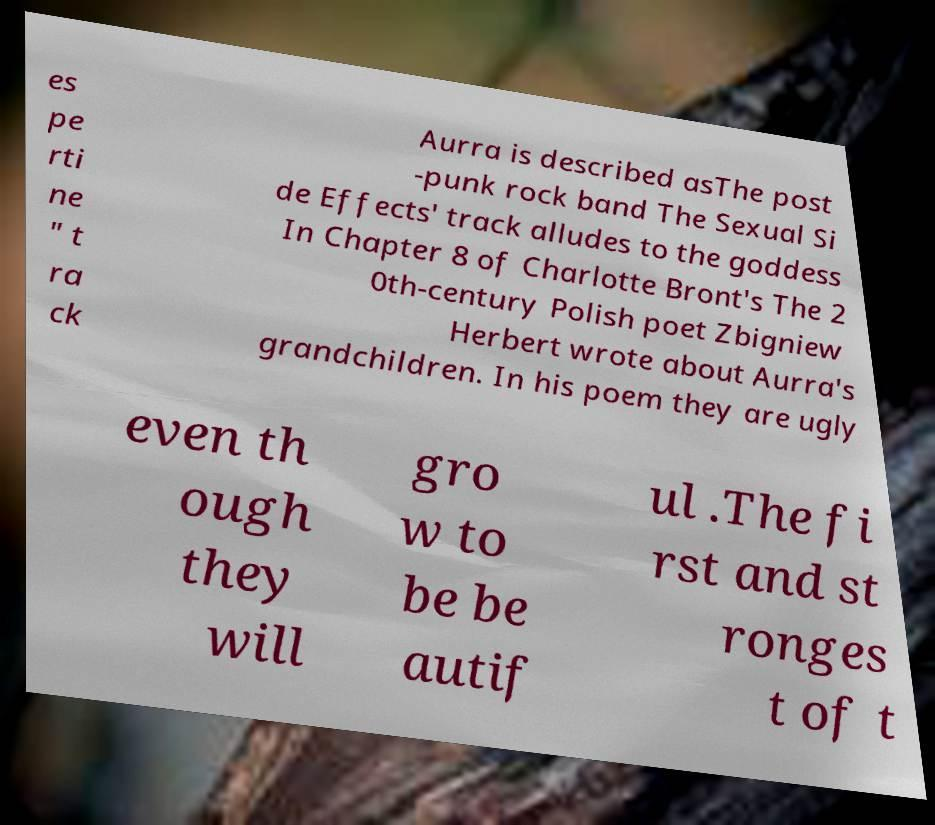There's text embedded in this image that I need extracted. Can you transcribe it verbatim? es pe rti ne " t ra ck Aurra is described asThe post -punk rock band The Sexual Si de Effects' track alludes to the goddess In Chapter 8 of Charlotte Bront's The 2 0th-century Polish poet Zbigniew Herbert wrote about Aurra's grandchildren. In his poem they are ugly even th ough they will gro w to be be autif ul .The fi rst and st ronges t of t 